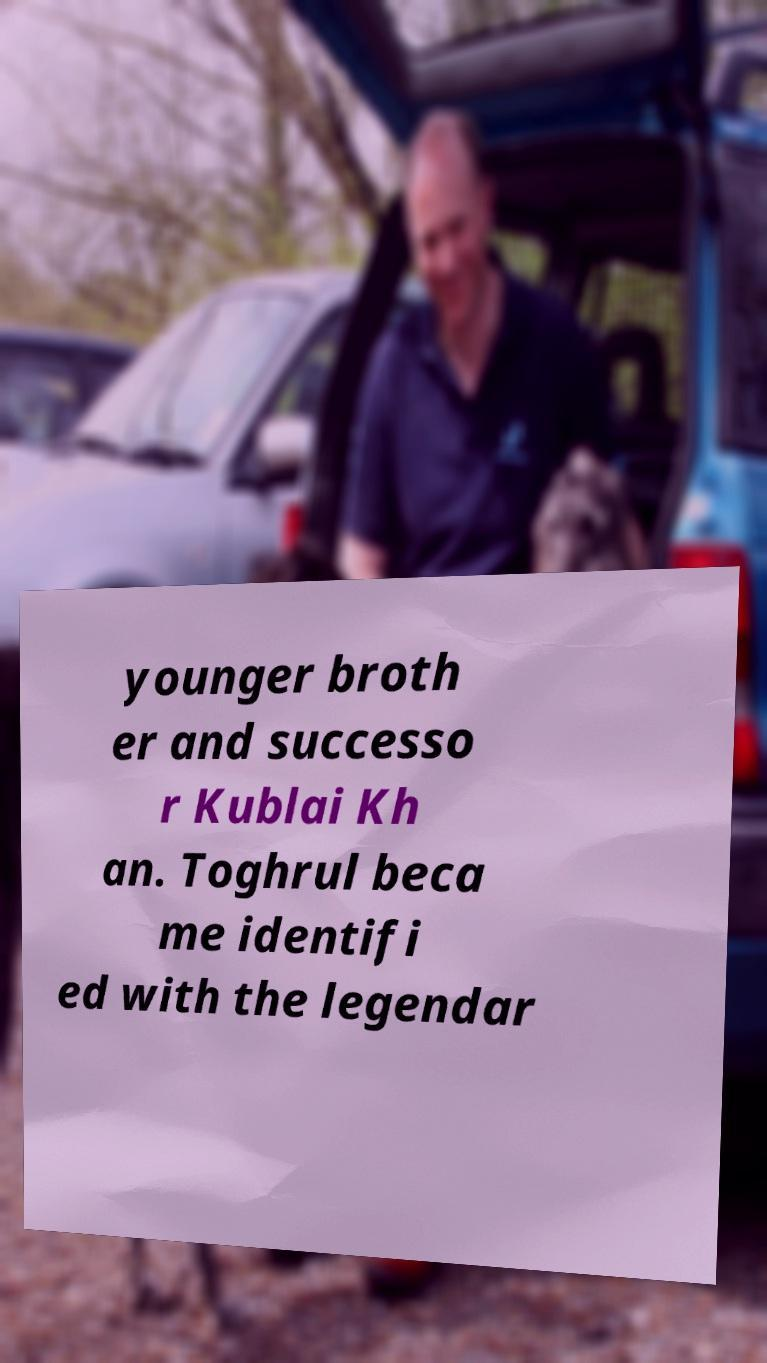I need the written content from this picture converted into text. Can you do that? younger broth er and successo r Kublai Kh an. Toghrul beca me identifi ed with the legendar 